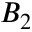<formula> <loc_0><loc_0><loc_500><loc_500>B _ { 2 }</formula> 